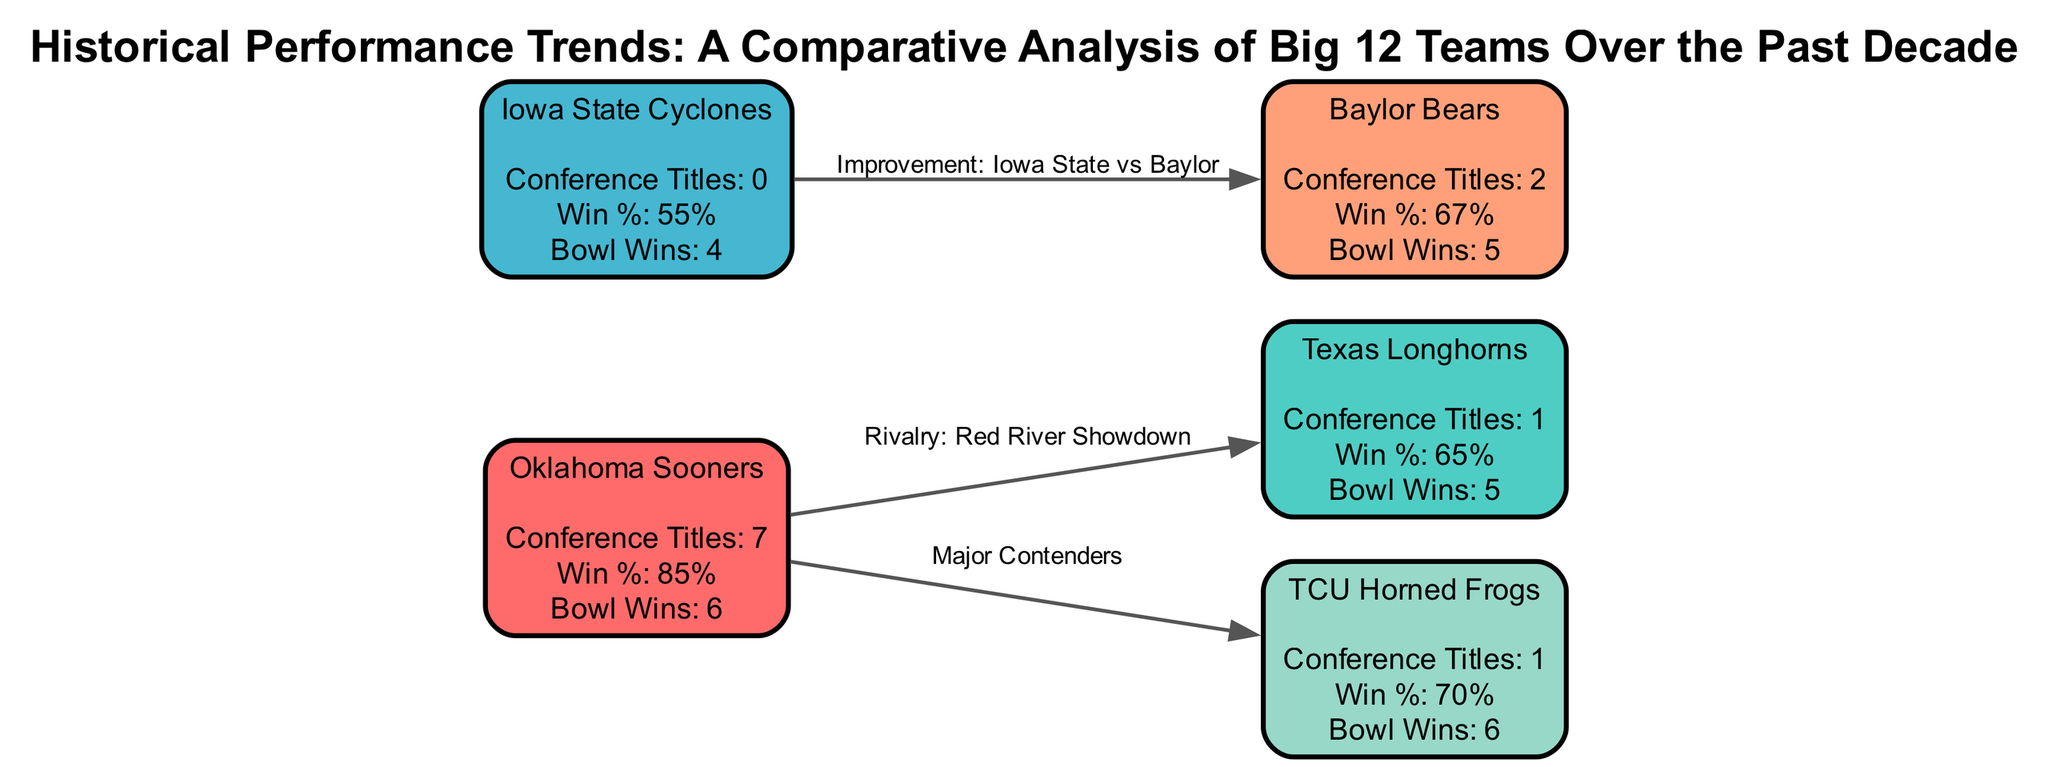What is the win percentage of the Oklahoma Sooners? The win percentage is indicated in the node for the Oklahoma Sooners, showing "Win %: 85%."
Answer: 85% How many conference titles does Texas Longhorns have? The number of conference titles is clearly listed under the Texas Longhorns node as "Conference Titles: 1."
Answer: 1 Which team has the highest win percentage? By comparing the win percentages of all teams shown, the Oklahoma Sooners have the highest at "Win %: 85%."
Answer: Oklahoma Sooners What is the rivalry game mentioned in the diagram? The edge labeled "Rivalry: Red River Showdown" connects the Oklahoma Sooners and Texas Longhorns nodes, identifying it as the rivalry game.
Answer: Red River Showdown How many bowl game wins do the Iowa State Cyclones have? The number of bowl game wins is listed in the Iowa State Cyclones node as "Bowl Wins: 4."
Answer: 4 Which team has no conference titles? Check the nodes for conference titles, and the Iowa State Cyclones node states "Conference Titles: 0."
Answer: Iowa State Cyclones Which teams have a win percentage above 65%? Analyze the win percentages: Oklahoma Sooners (85%) and TCU Horned Frogs (70%) are above 65%.
Answer: Oklahoma Sooners, TCU Horned Frogs What is the nature of the edge between Iowa State and Baylor? The edge labeled "Improvement: Iowa State vs Baylor" indicates the nature of their relationship.
Answer: Improvement How many edges are present in this diagram? Count the edges connecting the nodes, which total four as represented by the connections outlined in the edges list.
Answer: 3 